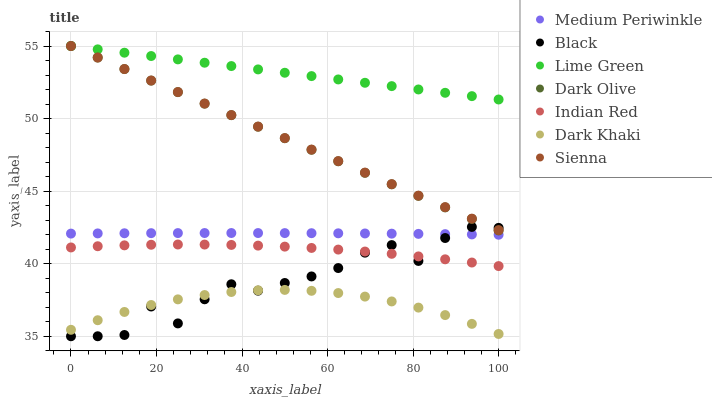Does Dark Khaki have the minimum area under the curve?
Answer yes or no. Yes. Does Lime Green have the maximum area under the curve?
Answer yes or no. Yes. Does Dark Olive have the minimum area under the curve?
Answer yes or no. No. Does Dark Olive have the maximum area under the curve?
Answer yes or no. No. Is Dark Olive the smoothest?
Answer yes or no. Yes. Is Black the roughest?
Answer yes or no. Yes. Is Medium Periwinkle the smoothest?
Answer yes or no. No. Is Medium Periwinkle the roughest?
Answer yes or no. No. Does Black have the lowest value?
Answer yes or no. Yes. Does Dark Olive have the lowest value?
Answer yes or no. No. Does Lime Green have the highest value?
Answer yes or no. Yes. Does Medium Periwinkle have the highest value?
Answer yes or no. No. Is Indian Red less than Lime Green?
Answer yes or no. Yes. Is Sienna greater than Indian Red?
Answer yes or no. Yes. Does Black intersect Sienna?
Answer yes or no. Yes. Is Black less than Sienna?
Answer yes or no. No. Is Black greater than Sienna?
Answer yes or no. No. Does Indian Red intersect Lime Green?
Answer yes or no. No. 